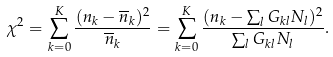Convert formula to latex. <formula><loc_0><loc_0><loc_500><loc_500>\chi ^ { 2 } = \sum _ { k = 0 } ^ { K } \frac { ( n _ { k } - \overline { n } _ { k } ) ^ { 2 } } { \overline { n } _ { k } } = \sum _ { k = 0 } ^ { K } \frac { ( n _ { k } - \sum _ { l } G _ { k l } N _ { l } ) ^ { 2 } } { \sum _ { l } G _ { k l } N _ { l } } .</formula> 